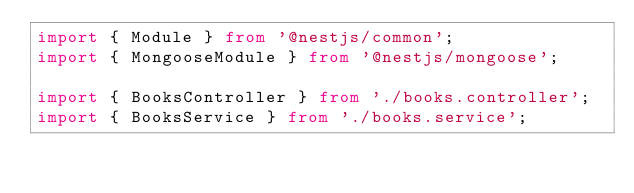<code> <loc_0><loc_0><loc_500><loc_500><_TypeScript_>import { Module } from '@nestjs/common';
import { MongooseModule } from '@nestjs/mongoose';

import { BooksController } from './books.controller';
import { BooksService } from './books.service';</code> 